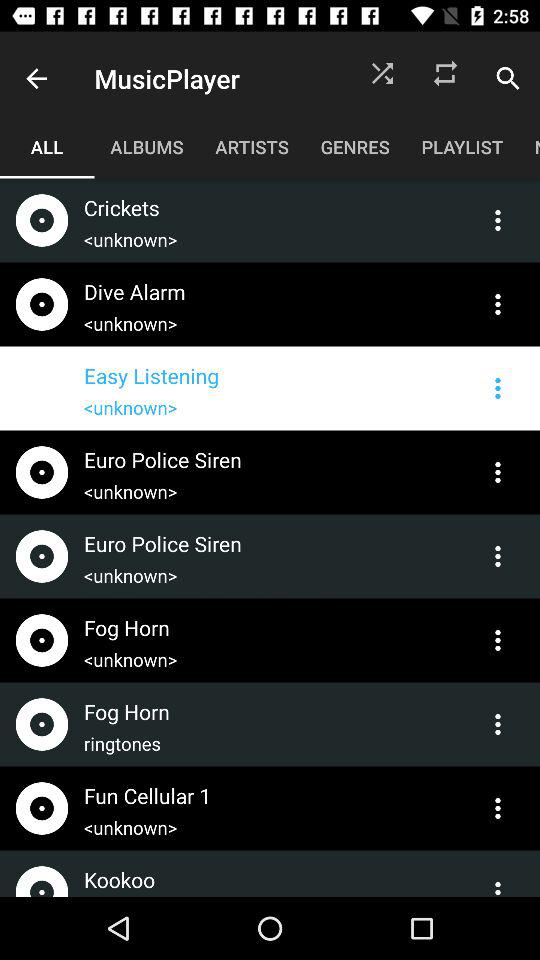What is the application name?
When the provided information is insufficient, respond with <no answer>. <no answer> 